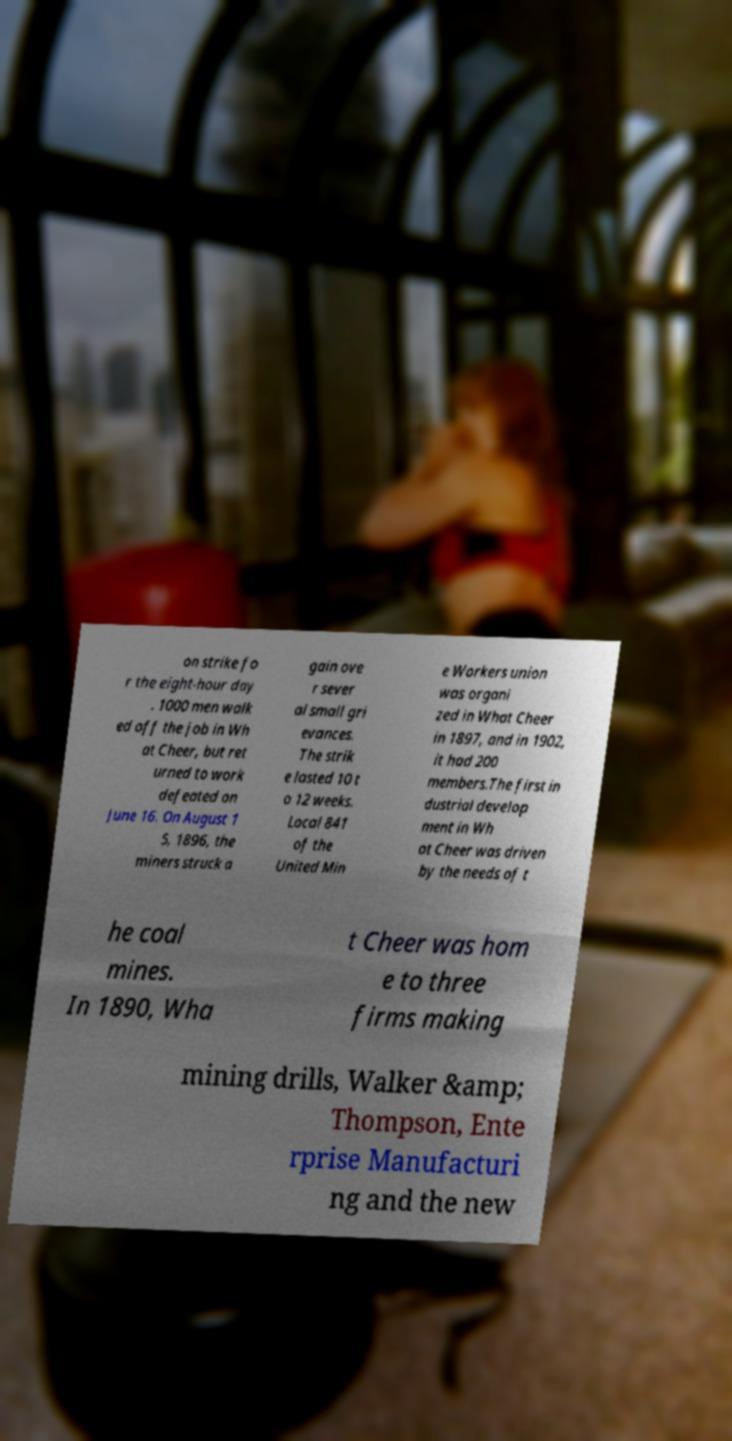Please read and relay the text visible in this image. What does it say? on strike fo r the eight-hour day . 1000 men walk ed off the job in Wh at Cheer, but ret urned to work defeated on June 16. On August 1 5, 1896, the miners struck a gain ove r sever al small gri evances. The strik e lasted 10 t o 12 weeks. Local 841 of the United Min e Workers union was organi zed in What Cheer in 1897, and in 1902, it had 200 members.The first in dustrial develop ment in Wh at Cheer was driven by the needs of t he coal mines. In 1890, Wha t Cheer was hom e to three firms making mining drills, Walker &amp; Thompson, Ente rprise Manufacturi ng and the new 